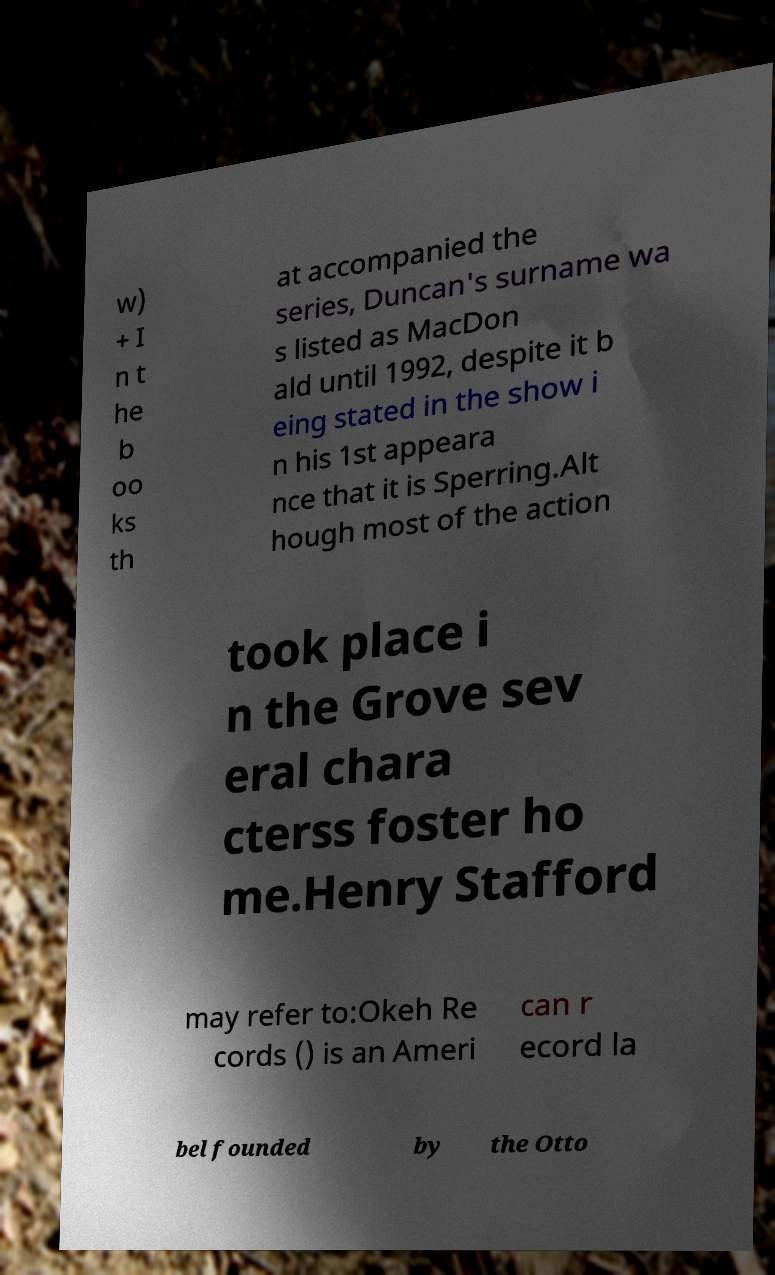Can you read and provide the text displayed in the image?This photo seems to have some interesting text. Can you extract and type it out for me? w) + I n t he b oo ks th at accompanied the series, Duncan's surname wa s listed as MacDon ald until 1992, despite it b eing stated in the show i n his 1st appeara nce that it is Sperring.Alt hough most of the action took place i n the Grove sev eral chara cterss foster ho me.Henry Stafford may refer to:Okeh Re cords () is an Ameri can r ecord la bel founded by the Otto 